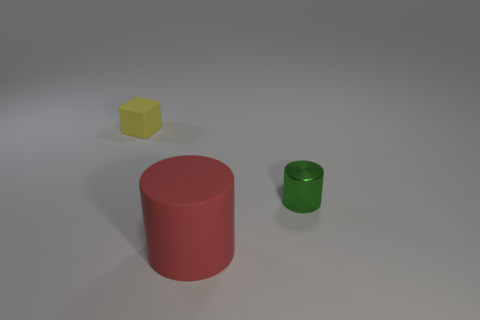There is a green thing that is the same shape as the big red object; what is it made of?
Your response must be concise. Metal. What is the material of the thing that is both in front of the tiny matte block and left of the tiny metallic thing?
Keep it short and to the point. Rubber. Is the small green thing made of the same material as the red thing?
Your response must be concise. No. There is a thing that is on the left side of the small green object and right of the yellow rubber thing; how big is it?
Make the answer very short. Large. The tiny rubber object is what shape?
Ensure brevity in your answer.  Cube. How many objects are green cylinders or cylinders that are to the left of the shiny object?
Provide a short and direct response. 2. Does the rubber object that is on the left side of the rubber cylinder have the same color as the tiny metallic thing?
Your answer should be compact. No. There is a thing that is both behind the large red thing and on the left side of the tiny green shiny thing; what is its color?
Make the answer very short. Yellow. There is a cylinder that is left of the green thing; what material is it?
Offer a very short reply. Rubber. How big is the red object?
Provide a succinct answer. Large. 